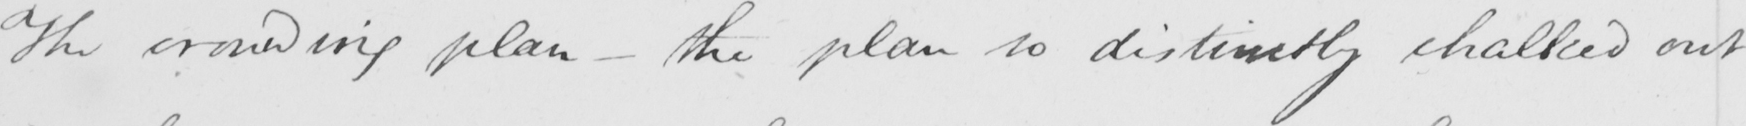Transcribe the text shown in this historical manuscript line. The crowding plan  _  the plan so distinctly chalked out 